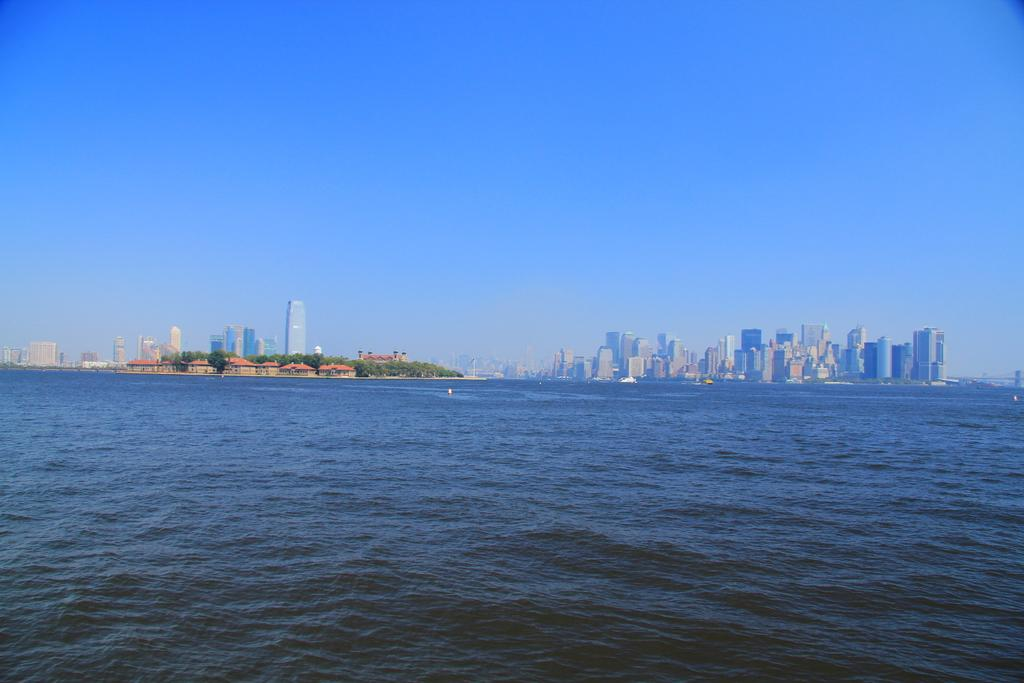What is the primary element visible in the image? There is water in the image. What can be seen in the distance behind the water? There are buildings and trees in the background of the image. What color is the sky in the image? The sky is blue in the image. How many books are floating on the water in the image? There are no books visible in the image; it only features water, buildings, trees, and a blue sky. 